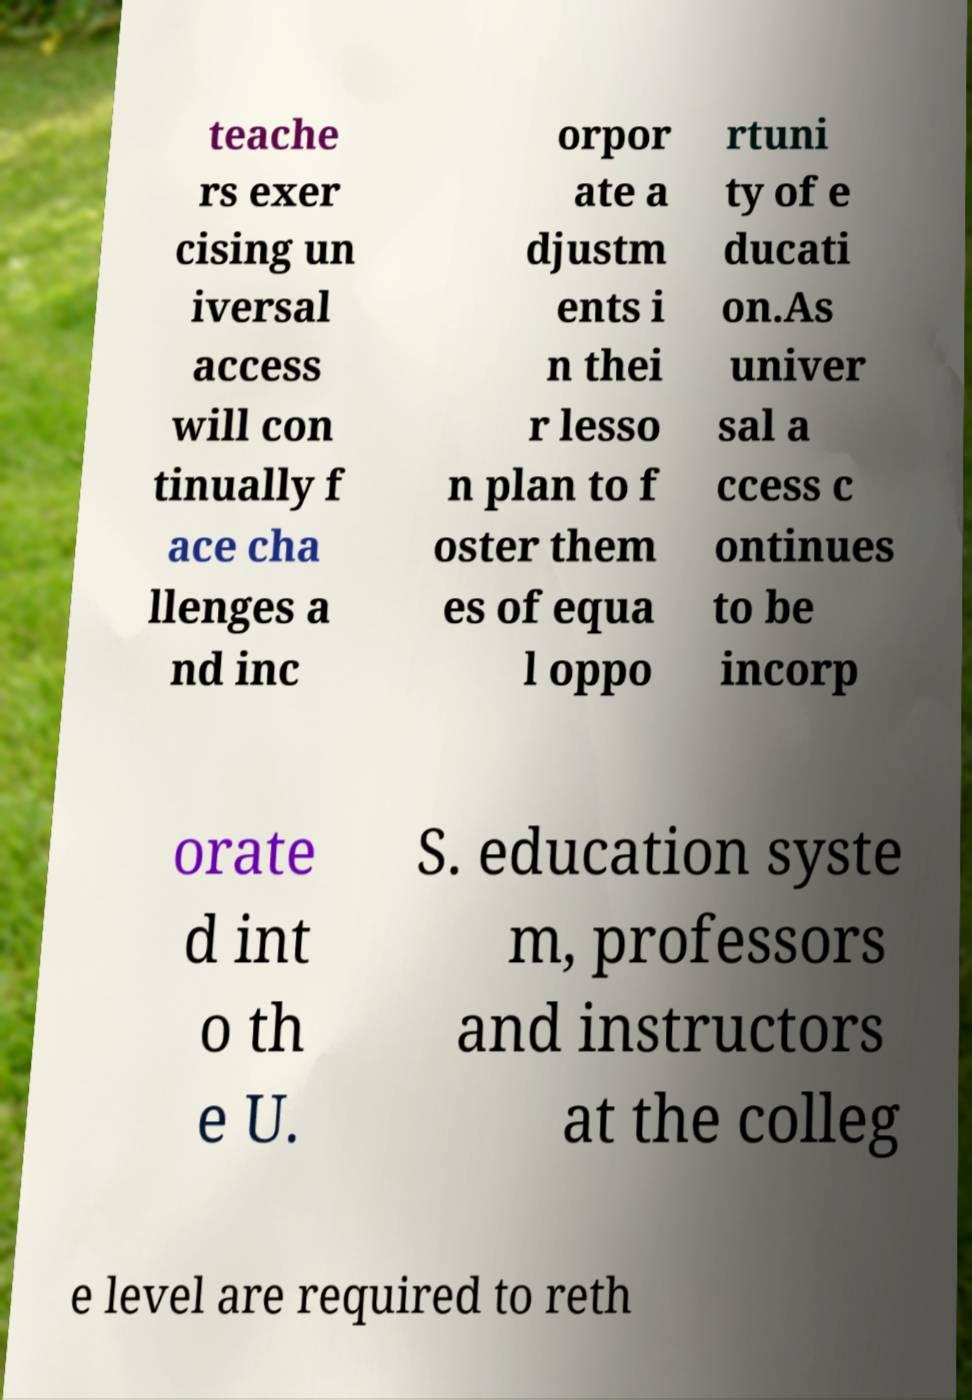Please read and relay the text visible in this image. What does it say? teache rs exer cising un iversal access will con tinually f ace cha llenges a nd inc orpor ate a djustm ents i n thei r lesso n plan to f oster them es of equa l oppo rtuni ty of e ducati on.As univer sal a ccess c ontinues to be incorp orate d int o th e U. S. education syste m, professors and instructors at the colleg e level are required to reth 